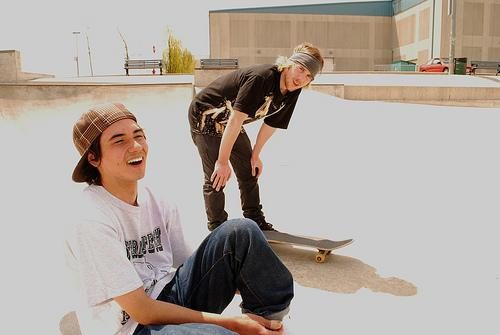Question: what is on his head?
Choices:
A. Helmet.
B. Sunglasses.
C. Hat.
D. Hair.
Answer with the letter. Answer: C Question: who is wearing the hat?
Choices:
A. The girl.
B. The baby.
C. The child.
D. The guy.
Answer with the letter. Answer: D Question: what are the people doing?
Choices:
A. Laughing.
B. Crying.
C. Smiling.
D. Applauding.
Answer with the letter. Answer: A Question: where are they?
Choices:
A. Outside.
B. Inside.
C. On a ramp.
D. In the car.
Answer with the letter. Answer: C Question: what is behind them?
Choices:
A. Car.
B. Animal.
C. Building.
D. Monster.
Answer with the letter. Answer: C 